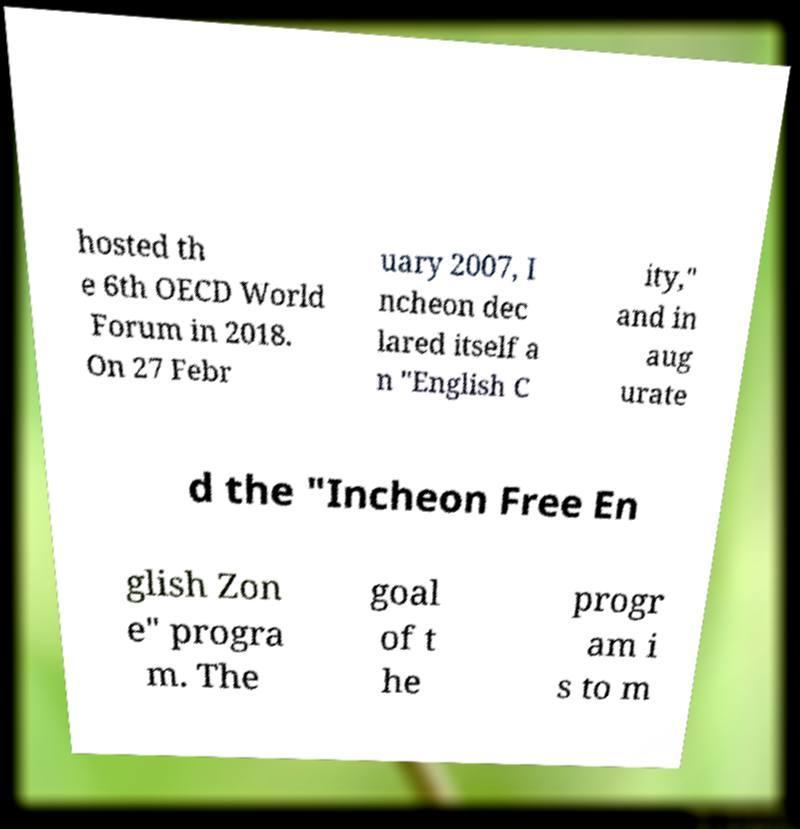Can you accurately transcribe the text from the provided image for me? hosted th e 6th OECD World Forum in 2018. On 27 Febr uary 2007, I ncheon dec lared itself a n "English C ity," and in aug urate d the "Incheon Free En glish Zon e" progra m. The goal of t he progr am i s to m 